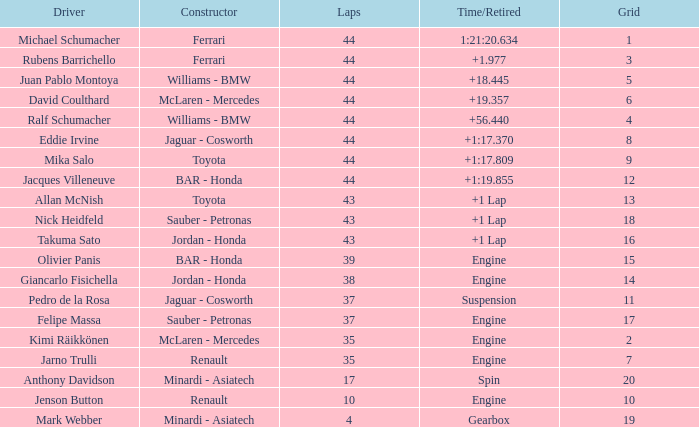What was the least amount of laps for a person who finished +1 44.0. 